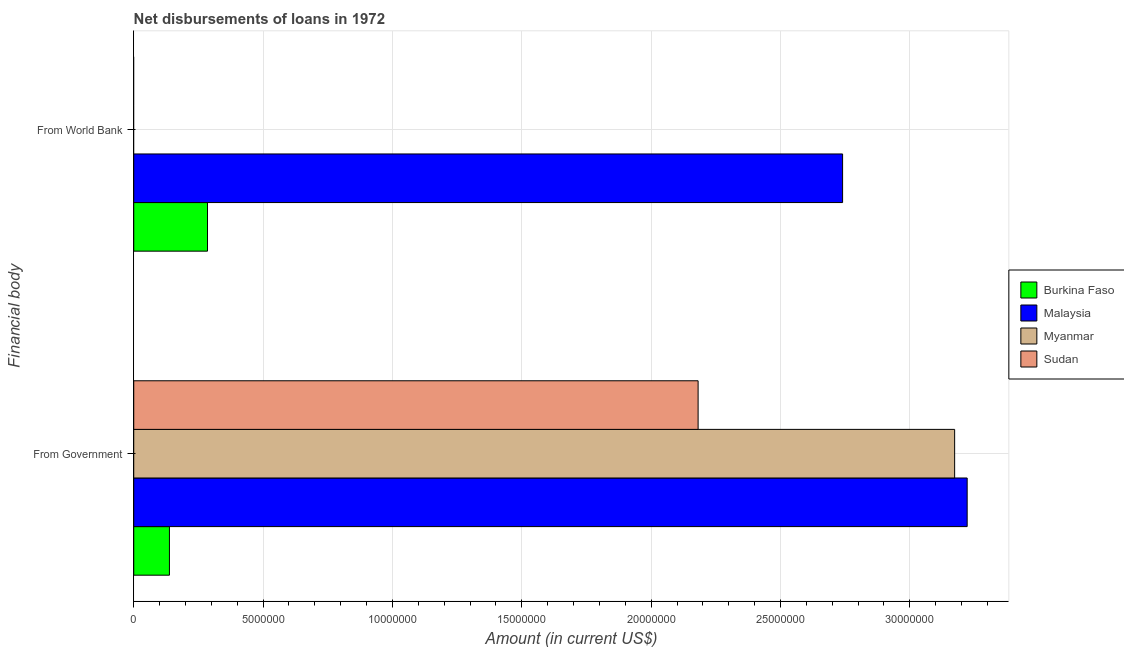How many groups of bars are there?
Your answer should be very brief. 2. What is the label of the 1st group of bars from the top?
Make the answer very short. From World Bank. Across all countries, what is the maximum net disbursements of loan from world bank?
Provide a succinct answer. 2.74e+07. In which country was the net disbursements of loan from government maximum?
Make the answer very short. Malaysia. What is the total net disbursements of loan from world bank in the graph?
Offer a terse response. 3.03e+07. What is the difference between the net disbursements of loan from government in Myanmar and that in Malaysia?
Provide a short and direct response. -4.84e+05. What is the difference between the net disbursements of loan from world bank in Burkina Faso and the net disbursements of loan from government in Sudan?
Your answer should be very brief. -1.90e+07. What is the average net disbursements of loan from government per country?
Your answer should be very brief. 2.18e+07. What is the difference between the net disbursements of loan from world bank and net disbursements of loan from government in Malaysia?
Offer a very short reply. -4.82e+06. In how many countries, is the net disbursements of loan from government greater than 8000000 US$?
Provide a short and direct response. 3. What is the ratio of the net disbursements of loan from government in Burkina Faso to that in Malaysia?
Keep it short and to the point. 0.04. In how many countries, is the net disbursements of loan from world bank greater than the average net disbursements of loan from world bank taken over all countries?
Your answer should be compact. 1. Are all the bars in the graph horizontal?
Your answer should be compact. Yes. Does the graph contain any zero values?
Your response must be concise. Yes. Does the graph contain grids?
Offer a very short reply. Yes. What is the title of the graph?
Offer a terse response. Net disbursements of loans in 1972. What is the label or title of the X-axis?
Provide a succinct answer. Amount (in current US$). What is the label or title of the Y-axis?
Keep it short and to the point. Financial body. What is the Amount (in current US$) in Burkina Faso in From Government?
Your answer should be compact. 1.38e+06. What is the Amount (in current US$) in Malaysia in From Government?
Keep it short and to the point. 3.22e+07. What is the Amount (in current US$) in Myanmar in From Government?
Your answer should be compact. 3.17e+07. What is the Amount (in current US$) of Sudan in From Government?
Offer a very short reply. 2.18e+07. What is the Amount (in current US$) of Burkina Faso in From World Bank?
Offer a very short reply. 2.85e+06. What is the Amount (in current US$) in Malaysia in From World Bank?
Offer a very short reply. 2.74e+07. What is the Amount (in current US$) of Sudan in From World Bank?
Keep it short and to the point. 0. Across all Financial body, what is the maximum Amount (in current US$) of Burkina Faso?
Keep it short and to the point. 2.85e+06. Across all Financial body, what is the maximum Amount (in current US$) of Malaysia?
Give a very brief answer. 3.22e+07. Across all Financial body, what is the maximum Amount (in current US$) in Myanmar?
Offer a very short reply. 3.17e+07. Across all Financial body, what is the maximum Amount (in current US$) in Sudan?
Make the answer very short. 2.18e+07. Across all Financial body, what is the minimum Amount (in current US$) of Burkina Faso?
Ensure brevity in your answer.  1.38e+06. Across all Financial body, what is the minimum Amount (in current US$) in Malaysia?
Provide a succinct answer. 2.74e+07. Across all Financial body, what is the minimum Amount (in current US$) of Myanmar?
Provide a short and direct response. 0. Across all Financial body, what is the minimum Amount (in current US$) of Sudan?
Your response must be concise. 0. What is the total Amount (in current US$) of Burkina Faso in the graph?
Make the answer very short. 4.23e+06. What is the total Amount (in current US$) of Malaysia in the graph?
Your answer should be compact. 5.96e+07. What is the total Amount (in current US$) of Myanmar in the graph?
Provide a short and direct response. 3.17e+07. What is the total Amount (in current US$) of Sudan in the graph?
Ensure brevity in your answer.  2.18e+07. What is the difference between the Amount (in current US$) of Burkina Faso in From Government and that in From World Bank?
Provide a short and direct response. -1.47e+06. What is the difference between the Amount (in current US$) of Malaysia in From Government and that in From World Bank?
Ensure brevity in your answer.  4.82e+06. What is the difference between the Amount (in current US$) of Burkina Faso in From Government and the Amount (in current US$) of Malaysia in From World Bank?
Your answer should be compact. -2.60e+07. What is the average Amount (in current US$) in Burkina Faso per Financial body?
Keep it short and to the point. 2.12e+06. What is the average Amount (in current US$) of Malaysia per Financial body?
Provide a succinct answer. 2.98e+07. What is the average Amount (in current US$) of Myanmar per Financial body?
Your answer should be compact. 1.59e+07. What is the average Amount (in current US$) of Sudan per Financial body?
Make the answer very short. 1.09e+07. What is the difference between the Amount (in current US$) of Burkina Faso and Amount (in current US$) of Malaysia in From Government?
Your answer should be very brief. -3.08e+07. What is the difference between the Amount (in current US$) of Burkina Faso and Amount (in current US$) of Myanmar in From Government?
Your response must be concise. -3.04e+07. What is the difference between the Amount (in current US$) in Burkina Faso and Amount (in current US$) in Sudan in From Government?
Your answer should be very brief. -2.04e+07. What is the difference between the Amount (in current US$) of Malaysia and Amount (in current US$) of Myanmar in From Government?
Provide a short and direct response. 4.84e+05. What is the difference between the Amount (in current US$) of Malaysia and Amount (in current US$) of Sudan in From Government?
Keep it short and to the point. 1.04e+07. What is the difference between the Amount (in current US$) in Myanmar and Amount (in current US$) in Sudan in From Government?
Make the answer very short. 9.92e+06. What is the difference between the Amount (in current US$) of Burkina Faso and Amount (in current US$) of Malaysia in From World Bank?
Keep it short and to the point. -2.45e+07. What is the ratio of the Amount (in current US$) in Burkina Faso in From Government to that in From World Bank?
Your answer should be compact. 0.48. What is the ratio of the Amount (in current US$) of Malaysia in From Government to that in From World Bank?
Give a very brief answer. 1.18. What is the difference between the highest and the second highest Amount (in current US$) in Burkina Faso?
Your response must be concise. 1.47e+06. What is the difference between the highest and the second highest Amount (in current US$) of Malaysia?
Your answer should be compact. 4.82e+06. What is the difference between the highest and the lowest Amount (in current US$) in Burkina Faso?
Offer a terse response. 1.47e+06. What is the difference between the highest and the lowest Amount (in current US$) in Malaysia?
Your answer should be compact. 4.82e+06. What is the difference between the highest and the lowest Amount (in current US$) in Myanmar?
Your answer should be compact. 3.17e+07. What is the difference between the highest and the lowest Amount (in current US$) of Sudan?
Provide a succinct answer. 2.18e+07. 